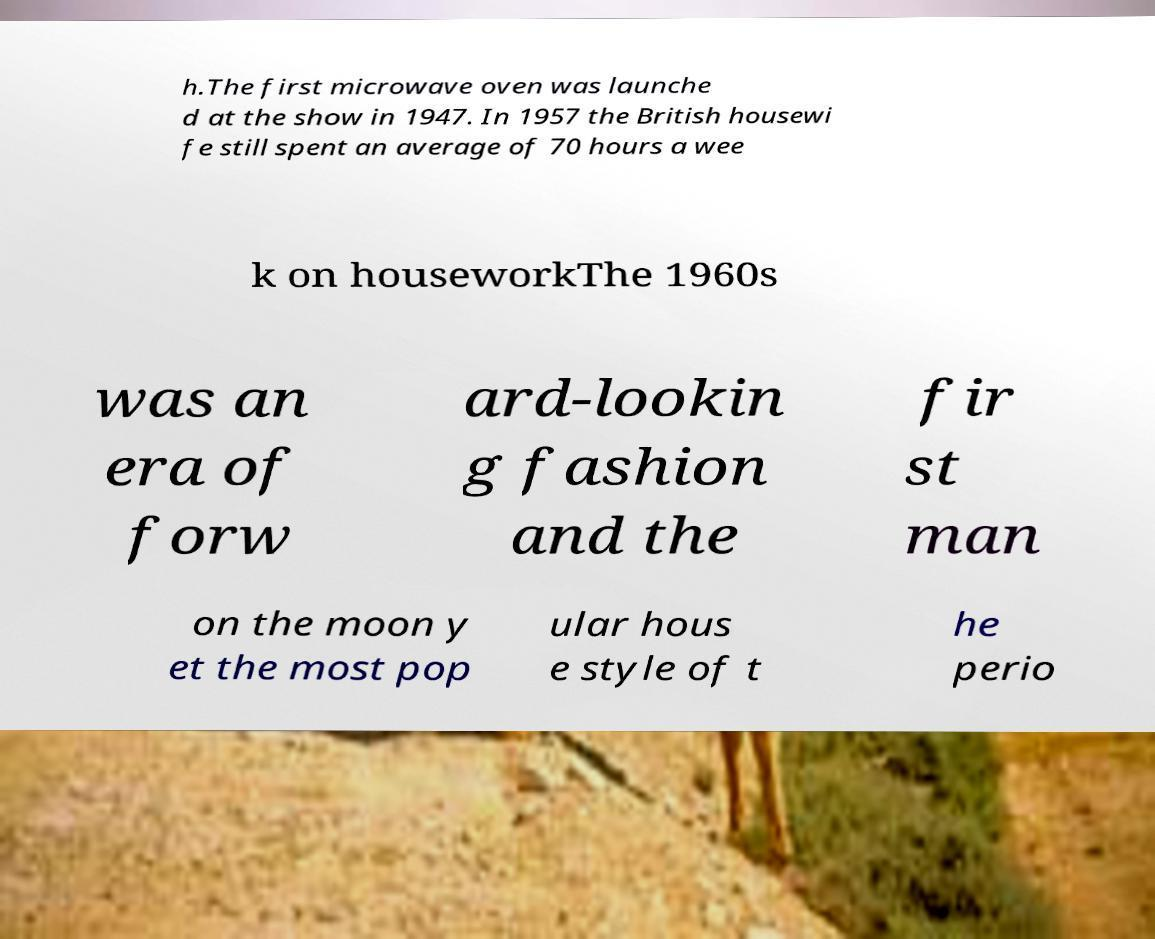For documentation purposes, I need the text within this image transcribed. Could you provide that? h.The first microwave oven was launche d at the show in 1947. In 1957 the British housewi fe still spent an average of 70 hours a wee k on houseworkThe 1960s was an era of forw ard-lookin g fashion and the fir st man on the moon y et the most pop ular hous e style of t he perio 